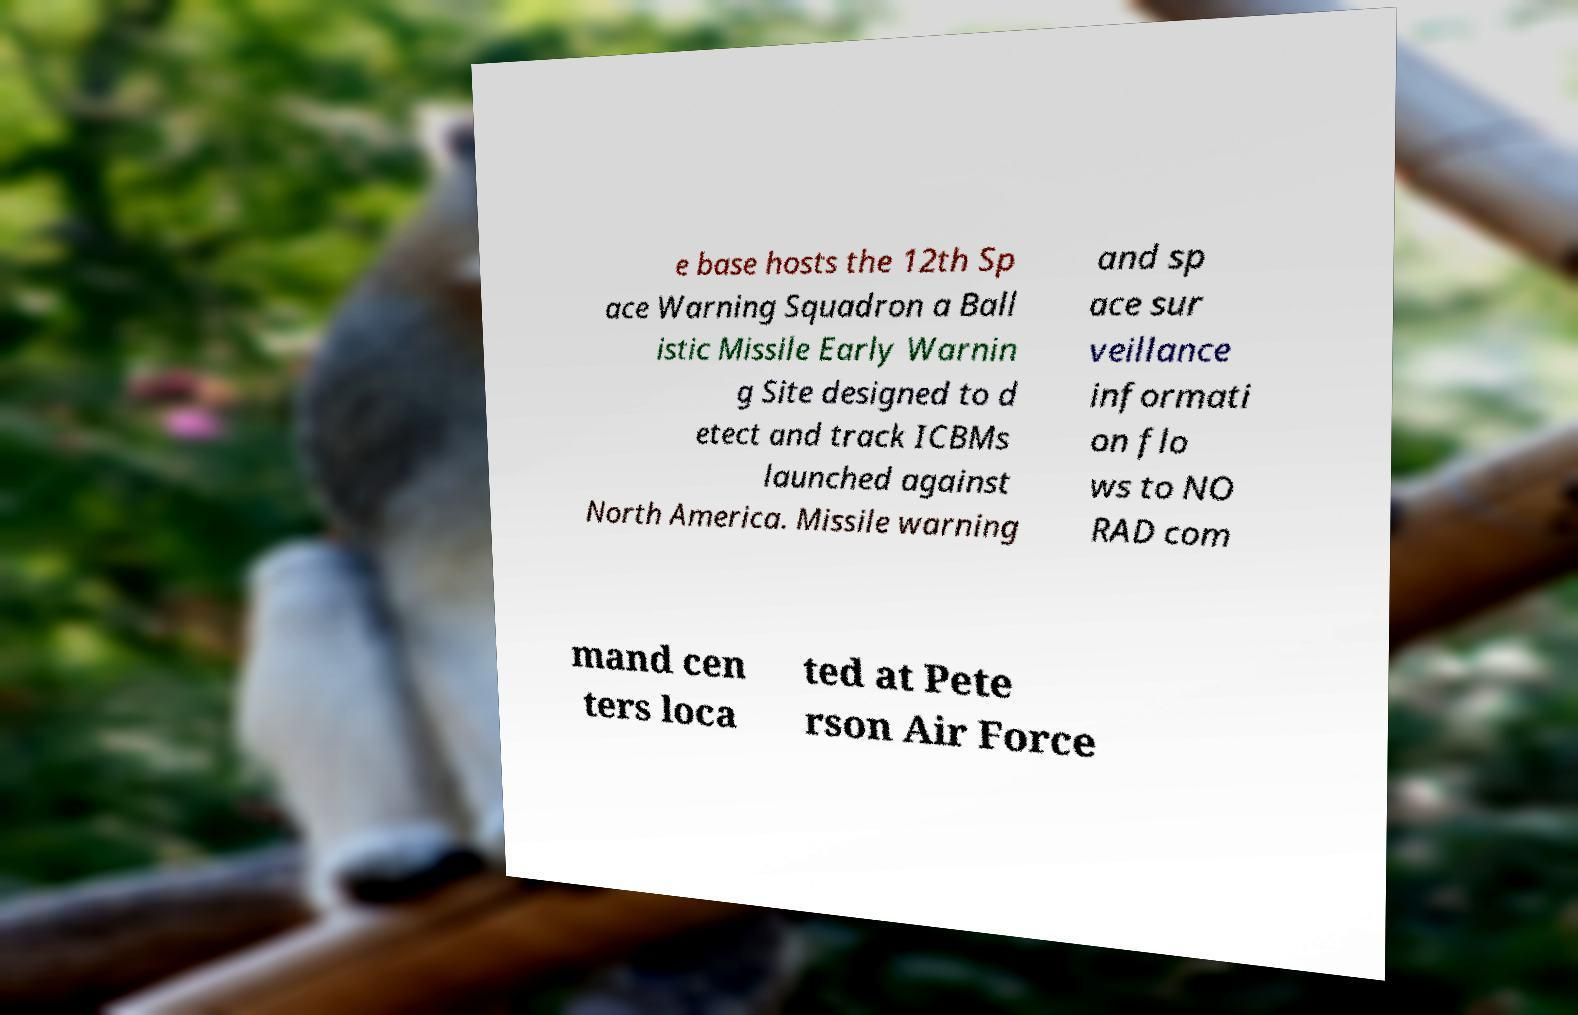For documentation purposes, I need the text within this image transcribed. Could you provide that? e base hosts the 12th Sp ace Warning Squadron a Ball istic Missile Early Warnin g Site designed to d etect and track ICBMs launched against North America. Missile warning and sp ace sur veillance informati on flo ws to NO RAD com mand cen ters loca ted at Pete rson Air Force 